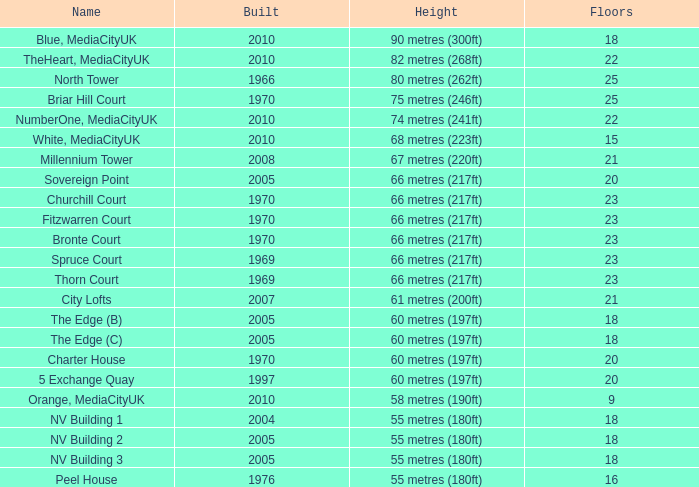For a building with a rank of 3 and over 23 floors, what is the lowest possible height? 1966.0. 